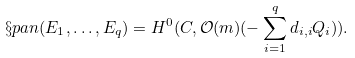Convert formula to latex. <formula><loc_0><loc_0><loc_500><loc_500>\S p a n ( E _ { 1 } , \dots , E _ { q } ) = H ^ { 0 } ( C , \mathcal { O } ( m ) ( - \sum _ { i = 1 } ^ { q } d _ { i , i } Q _ { i } ) ) .</formula> 